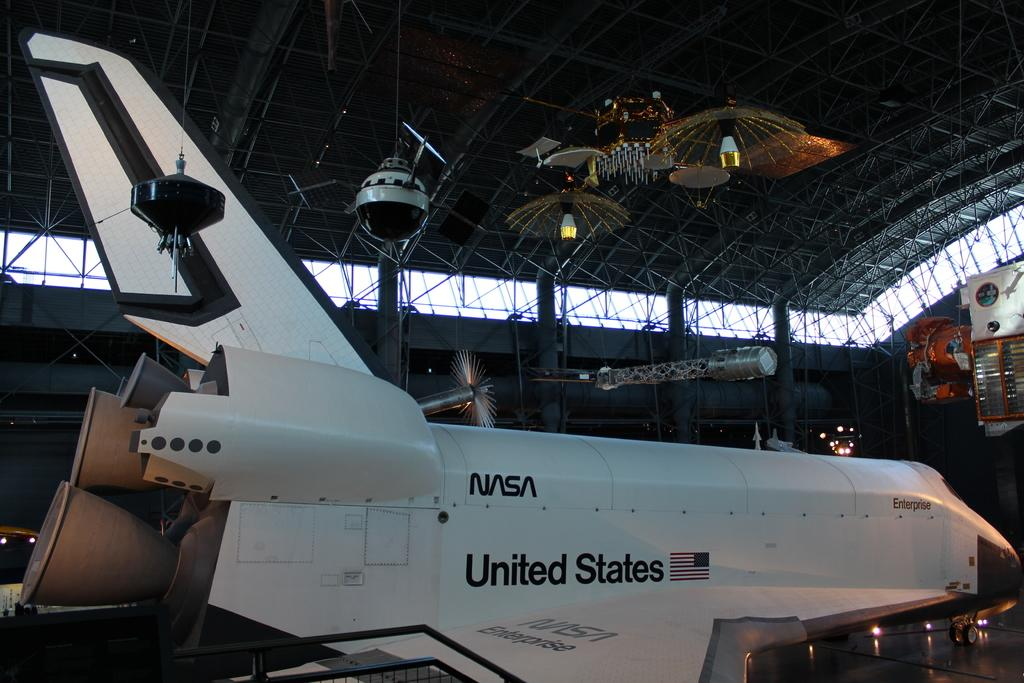What is placed on the floor in the image? There is an airplane on the floor. What structures can be seen in the image? There are poles in the image. What can be seen illuminating the area in the image? There are lights in the image. What else is present in the image besides the airplane, poles, and lights? There are objects in the image. What type of force is being applied to the basketball in the image? There is no basketball present in the image. What kind of apparel is being worn by the person in the image? There is no person or apparel visible in the image. 